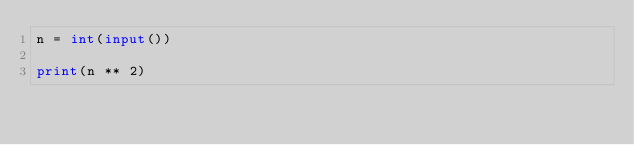Convert code to text. <code><loc_0><loc_0><loc_500><loc_500><_Python_>n = int(input())

print(n ** 2)</code> 